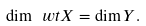Convert formula to latex. <formula><loc_0><loc_0><loc_500><loc_500>\dim \ w t X = \dim Y .</formula> 